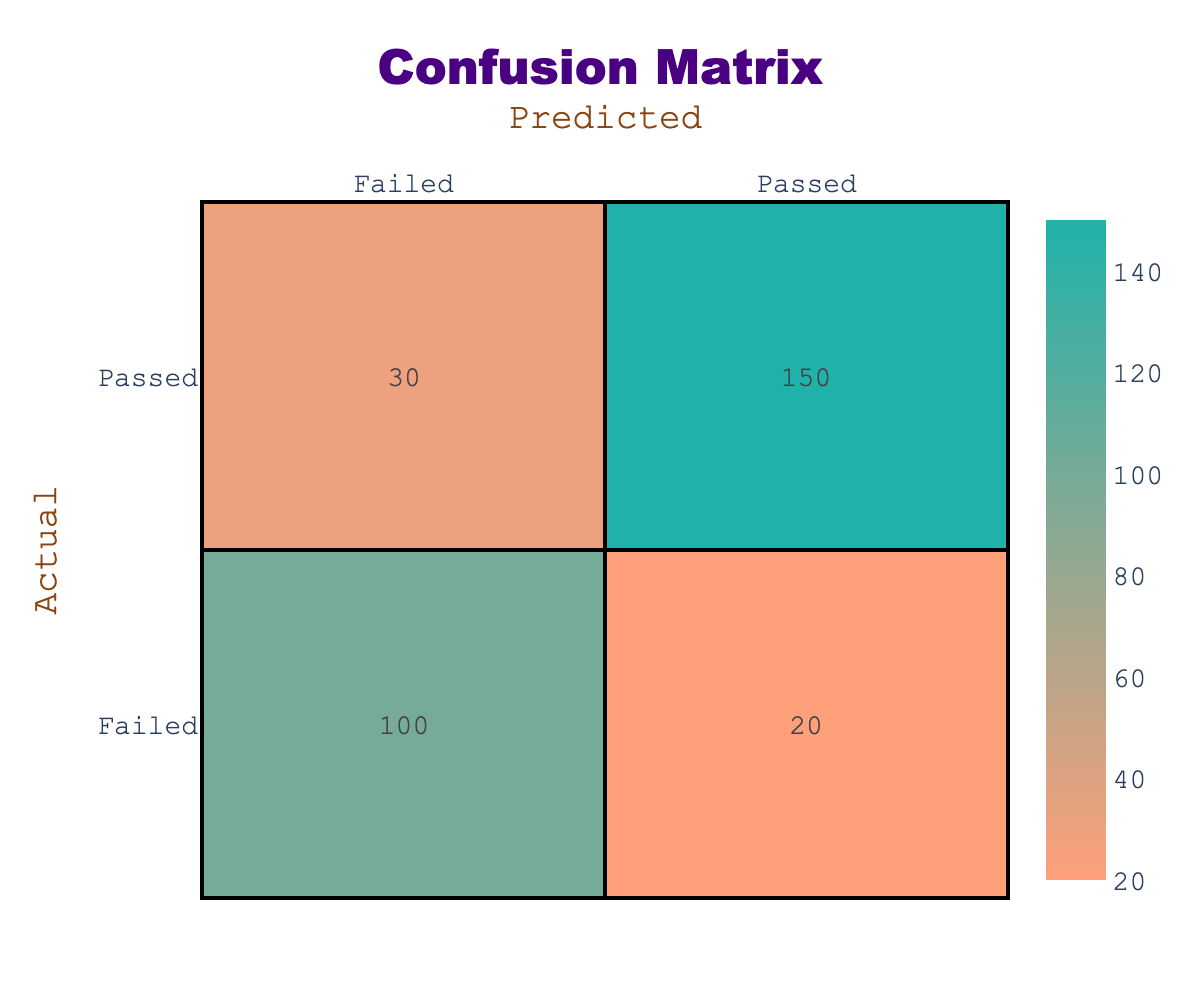What is the total number of students who passed the exam? To find the total number of students who passed, I need to sum the counts of both cases where the actual outcome is "Passed." The values for "Passed, Passed" is 150 and "Failed, Passed" is 20. So, the total is 150 + 20 = 170.
Answer: 170 What is the total number of students who failed the exam? To determine the number of students who failed the exam, I will sum the counts of both cases where the actual outcome is "Failed." The values for "Passed, Failed" is 30 and "Failed, Failed" is 100. Thus, the total is 30 + 100 = 130.
Answer: 130 Is it true that more students passed than failed based on the predicted outcome? To verify this, I will compare the totals for predicted outcomes. The total predicted as "Passed" is 150 (from Passed, Passed) + 20 (from Failed, Passed) = 170. The total predicted as "Failed" is 30 (from Passed, Failed) + 100 (from Failed, Failed) = 130. Since 170 is greater than 130, the statement is true.
Answer: Yes What is the percentage of students who were correctly predicted to pass? To calculate this, I will find the number of students who were correctly predicted to pass, which is 150, and divide it by the total number of students (150 + 30 + 20 + 100 = 300). The percentage is then (150 / 300) * 100 = 50%.
Answer: 50% What is the difference between the number of students who predicted passed and those predicted failed? I will find the totals for predicted outcomes: the total predicted "Passed" is 170, and "Failed" is 130. The difference is 170 - 130 = 40.
Answer: 40 How many students were incorrectly predicted to fail? The incorrect predictions for "Failed" are derived from the first category where actual is "Passed" but predicted is "Failed." Here, the value is 30.
Answer: 30 What is the total number of students whose exam predictions were correct? To find the total number of correct predictions, I will add the cases where the predicted matches the actual. This includes 150 (Passed, Passed) and 100 (Failed, Failed), so the total of correct predictions is 150 + 100 = 250.
Answer: 250 What is the percentage of all students who failed the exam? The total number of students is 300. The number of students who actually failed is 130. Thus, the percentage is (130 / 300) * 100 = 43.3%.
Answer: 43.3% What are the total counts for predicted outcomes? The total for predicted "Passed" is 170 and for "Failed" is 130. Thus, summarizing gives me 170 for "Passed" and 130 for "Failed" forward. This shows a total of students predicted as 300, confirming all are counted.
Answer: 170 for Passed, 130 for Failed 